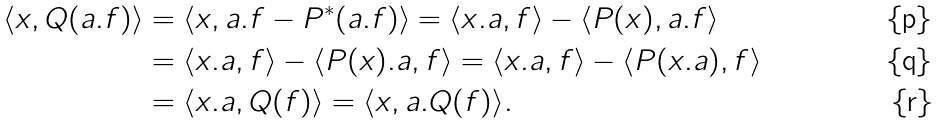<formula> <loc_0><loc_0><loc_500><loc_500>\langle x , Q ( a . f ) \rangle & = \langle x , a . f - P ^ { * } ( a . f ) \rangle = \langle x . a , f \rangle - \langle P ( x ) , a . f \rangle \\ & = \langle x . a , f \rangle - \langle P ( x ) . a , f \rangle = \langle x . a , f \rangle - \langle P ( x . a ) , f \rangle \\ & = \langle x . a , Q ( f ) \rangle = \langle x , a . Q ( f ) \rangle .</formula> 